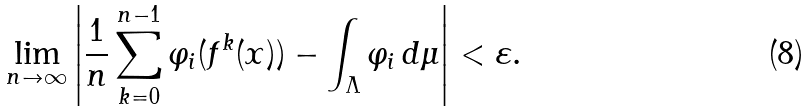<formula> <loc_0><loc_0><loc_500><loc_500>\lim _ { n \to \infty } \left | \frac { 1 } { n } \sum _ { k = 0 } ^ { n - 1 } \varphi _ { i } ( f ^ { k } ( x ) ) - \int _ { \Lambda } \varphi _ { i } \, d \mu \right | < \varepsilon .</formula> 